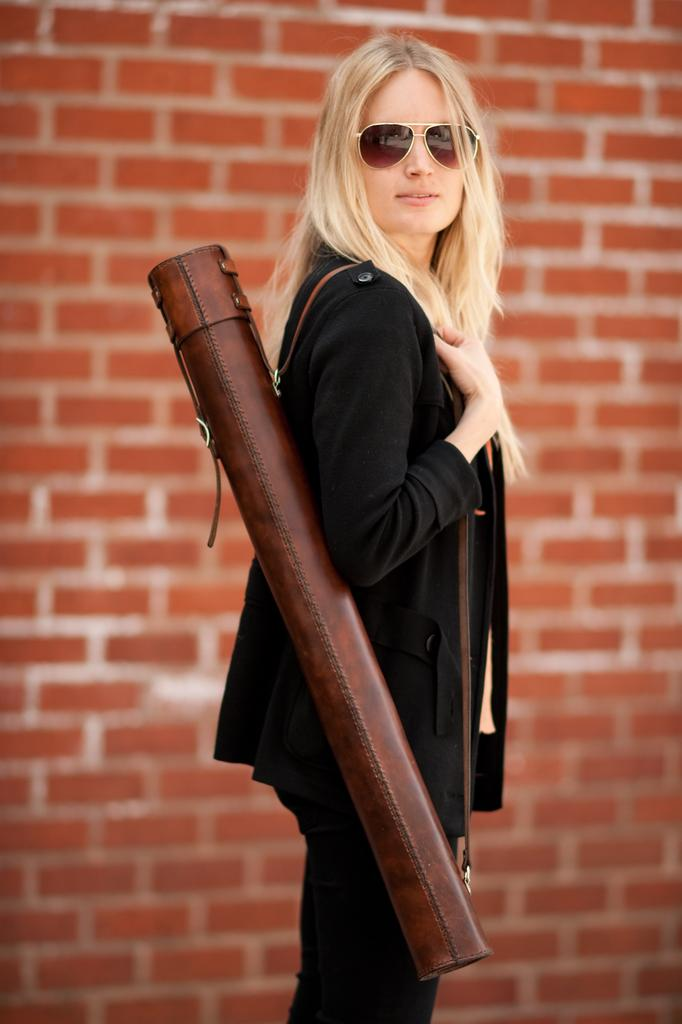Who is present in the image? There is a woman in the image. What is the woman doing in the image? The woman is standing in the image. What is the woman wearing in the image? The woman is wearing a bag in the image. What type of quiver can be seen on the woman's back in the image? There is no quiver present on the woman's back in the image. What kind of board is the woman using to balance in the image? The woman is not using a board to balance in the image; she is simply standing. 